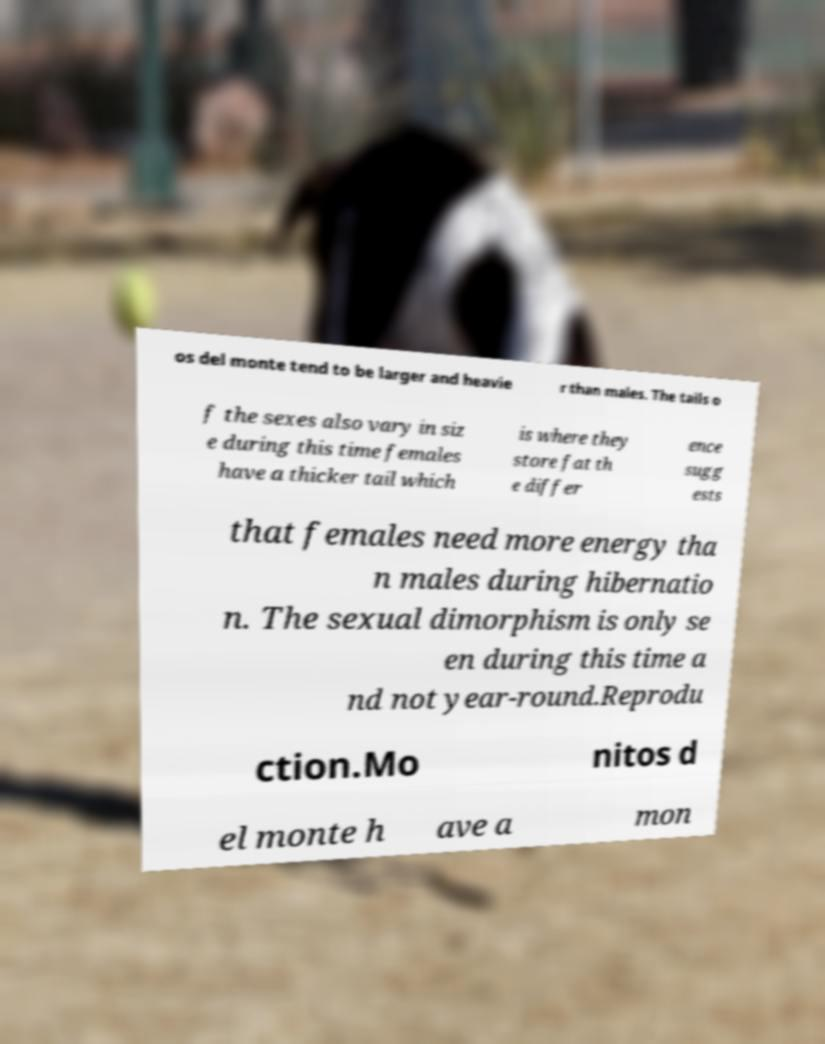Could you assist in decoding the text presented in this image and type it out clearly? os del monte tend to be larger and heavie r than males. The tails o f the sexes also vary in siz e during this time females have a thicker tail which is where they store fat th e differ ence sugg ests that females need more energy tha n males during hibernatio n. The sexual dimorphism is only se en during this time a nd not year-round.Reprodu ction.Mo nitos d el monte h ave a mon 